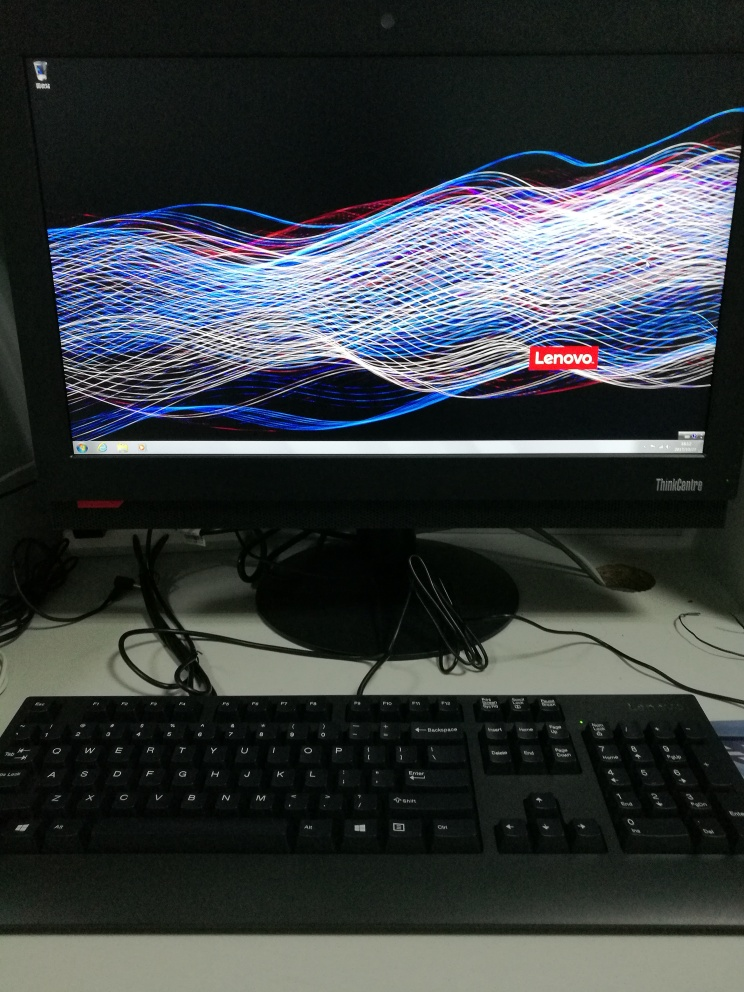What might this kind of image be commonly used for? The image on the monitor seems to be a screensaver or wallpaper commonly used to personalize the desktop and prevent screen burn-in on monitors. Such dynamic and colorful images are also useful for checking the monitor's color reproduction and contrast capabilities. 